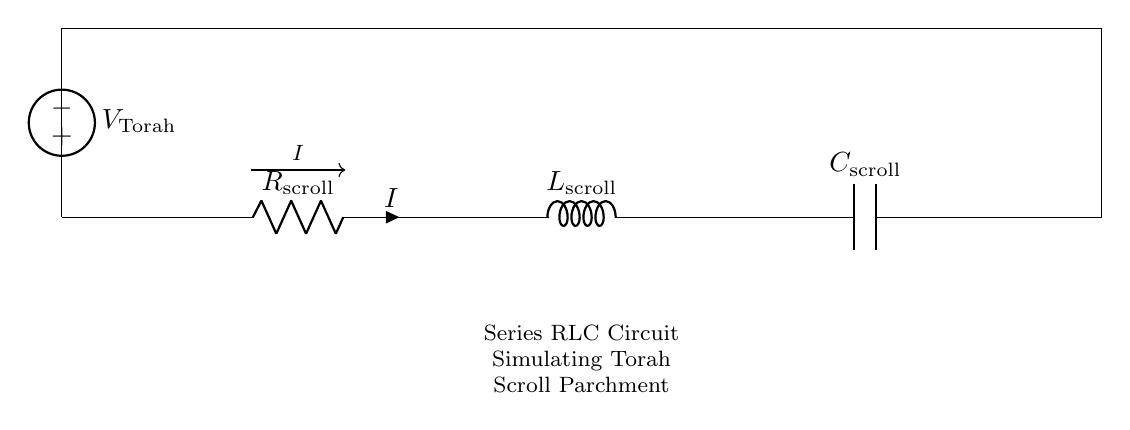What are the components present in the circuit? The circuit consists of a resistor, inductor, and capacitor, each labeled in the diagram. The specific labels are R for resistor, L for inductor, and C for capacitor.
Answer: Resistor, Inductor, Capacitor What does the voltage source represent? The voltage source labeled V is indicated as V Torah, which symbolizes the electrical energy supplied to the circuit, akin to the reverence and holiness associated with Torah.
Answer: V Torah What is the symbol for current in the circuit? The circuit diagram shows the current represented by the letter I with an arrow indicating direction, which is a standard convention in circuit diagrams to denote current flow.
Answer: I What is the function of the resistor in this circuit? The resistor's primary function is to limit or control the amount of current flowing through the circuit and is vital for simulating the resistance properties of Torah scroll parchment.
Answer: Limit current What is the purpose of the inductor in this configuration? The inductor stores energy in the form of a magnetic field when electrical current passes through it, which is significant in RLC circuits for creating resonance and controlling oscillations.
Answer: Store energy What is the main characteristic of the capacitor in this circuit? The capacitor's essential property is to store electric charge and energy when connected to the voltage source, releasing it when required, which is crucial for simulating the temporal behavior of the circuit.
Answer: Store charge How are the components connected in this circuit? The components are connected in series, meaning the current flows through the resistor, then the inductor, followed by the capacitor sequentially, which affects the overall impedance faced by the current.
Answer: In series 